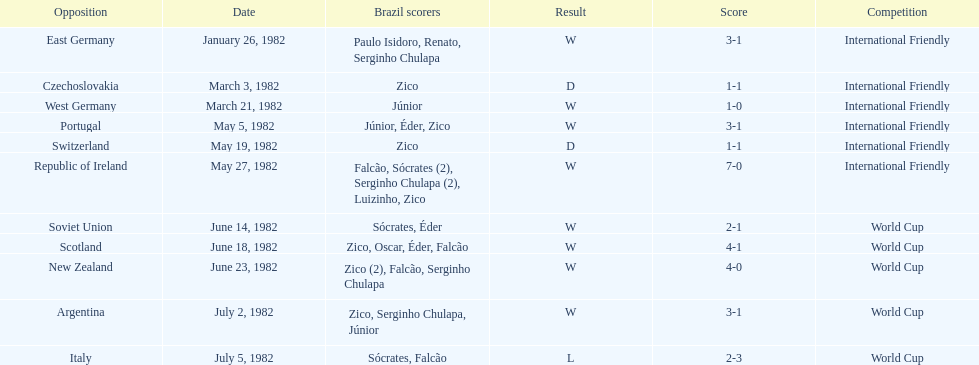What was the total number of losses brazil suffered? 1. 